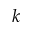Convert formula to latex. <formula><loc_0><loc_0><loc_500><loc_500>k</formula> 